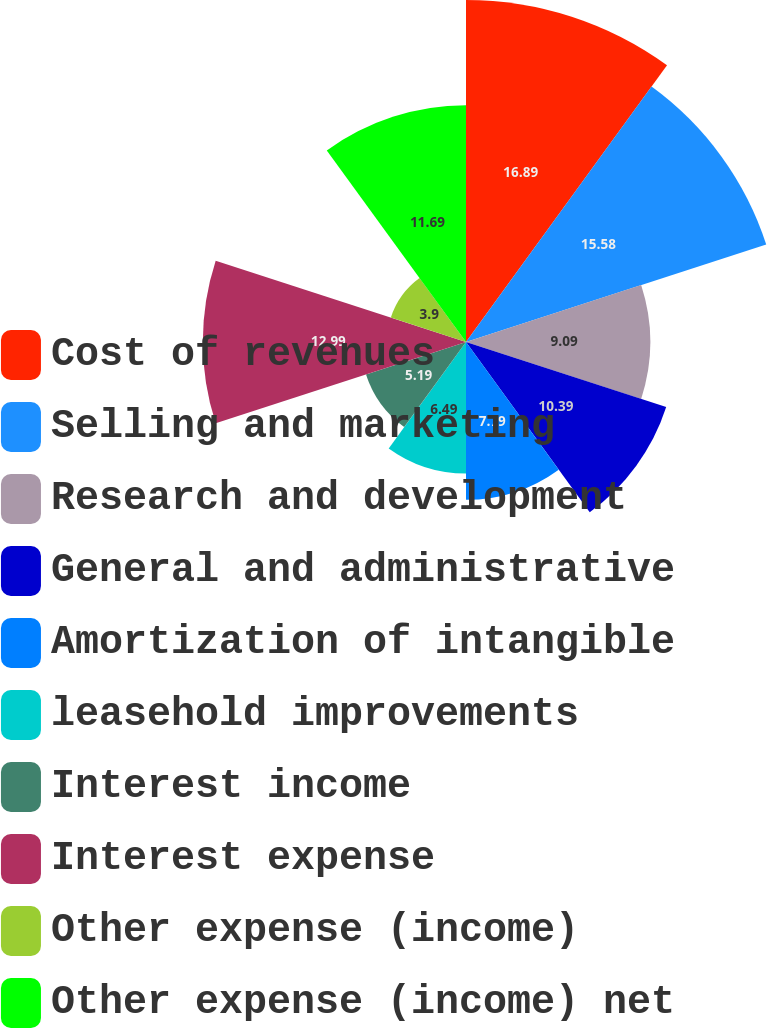Convert chart to OTSL. <chart><loc_0><loc_0><loc_500><loc_500><pie_chart><fcel>Cost of revenues<fcel>Selling and marketing<fcel>Research and development<fcel>General and administrative<fcel>Amortization of intangible<fcel>leasehold improvements<fcel>Interest income<fcel>Interest expense<fcel>Other expense (income)<fcel>Other expense (income) net<nl><fcel>16.88%<fcel>15.58%<fcel>9.09%<fcel>10.39%<fcel>7.79%<fcel>6.49%<fcel>5.19%<fcel>12.99%<fcel>3.9%<fcel>11.69%<nl></chart> 